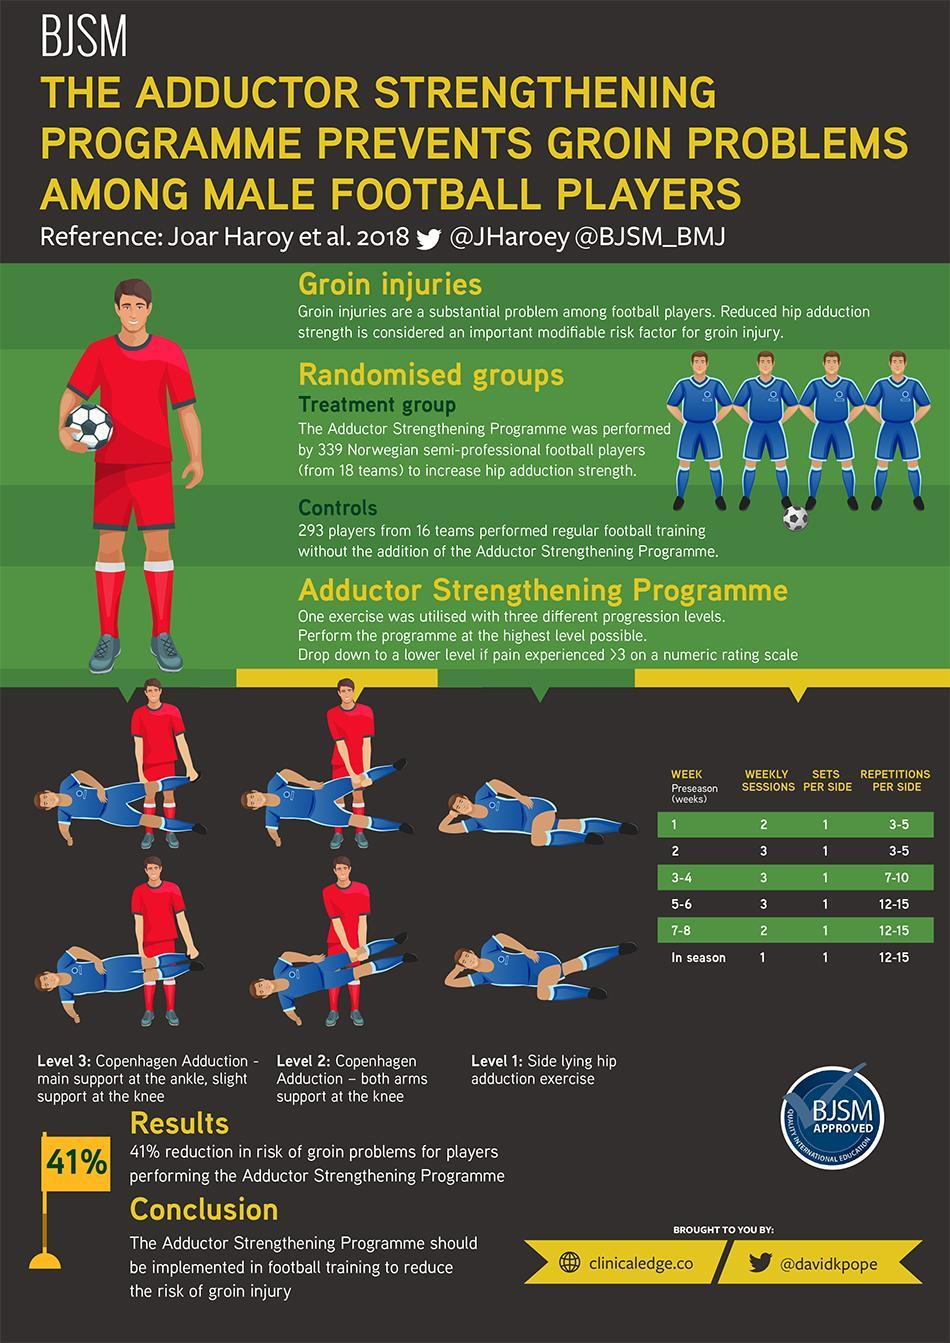What is the sets per side that has to be done every single week preseason?
Answer the question with a short phrase. 1 How many weekly sessions of the Adductor Strengthening Programme have to be conducted in week 1, 5 and 6? 2 How many repetitions per side have to be done during 5-6 weeks, 7-8 weeks, and in season? 12-15 Which weeks of the Adductor Strengthening Programme has 3 weekly sessions conducted? 2, 3-4, 5-6 Which weeks in the Adductor Strengthening Programme have the repetitions per side as 3-5 ? 1, 2 